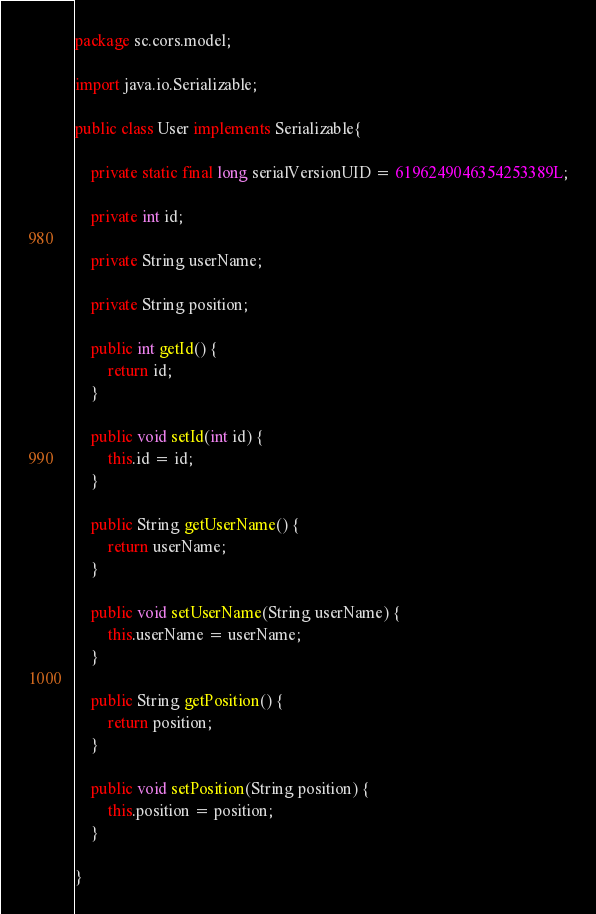<code> <loc_0><loc_0><loc_500><loc_500><_Java_>package sc.cors.model;

import java.io.Serializable;

public class User implements Serializable{

	private static final long serialVersionUID = 6196249046354253389L;

	private int id;
	
	private String userName;
	
	private String position;

	public int getId() {
		return id;
	}

	public void setId(int id) {
		this.id = id;
	}

	public String getUserName() {
		return userName;
	}

	public void setUserName(String userName) {
		this.userName = userName;
	}

	public String getPosition() {
		return position;
	}

	public void setPosition(String position) {
		this.position = position;
	}
	
}
</code> 